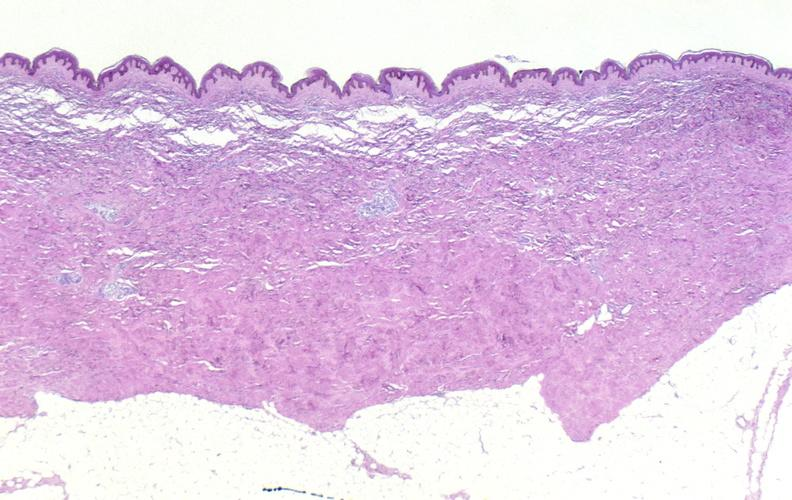does this image show scleroderma?
Answer the question using a single word or phrase. Yes 